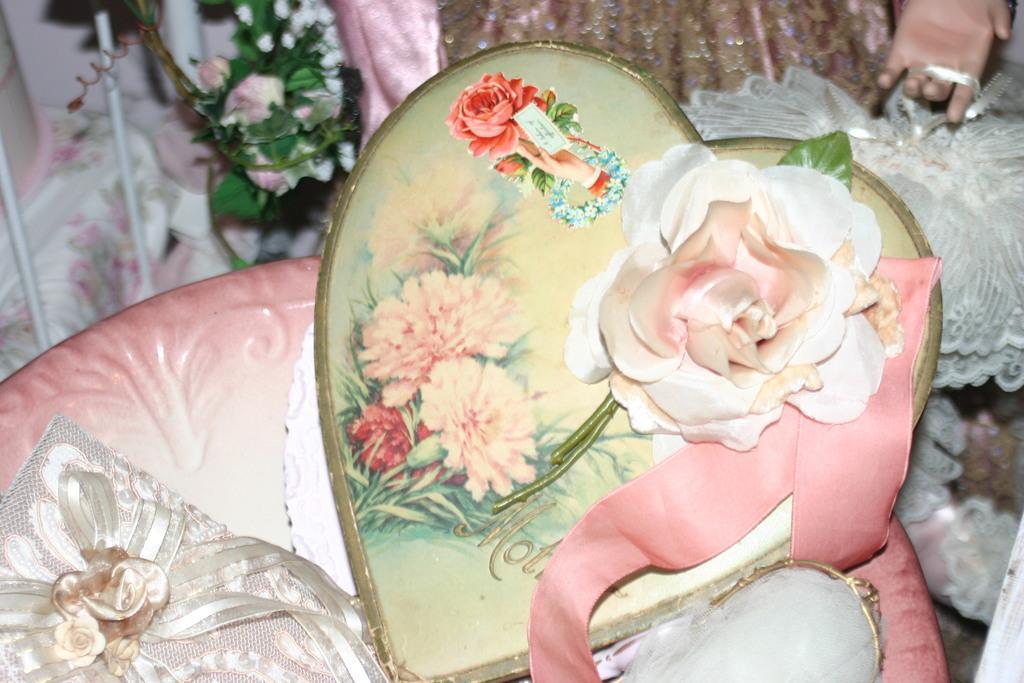Describe this image in one or two sentences. In this image, we can see heart shaped card with flower, stems, leaf and ribbon. At the bottom, we can see few things and plastic object. In the background we can see clothes, plastic flowers in basket, few things and hand of a toy. 